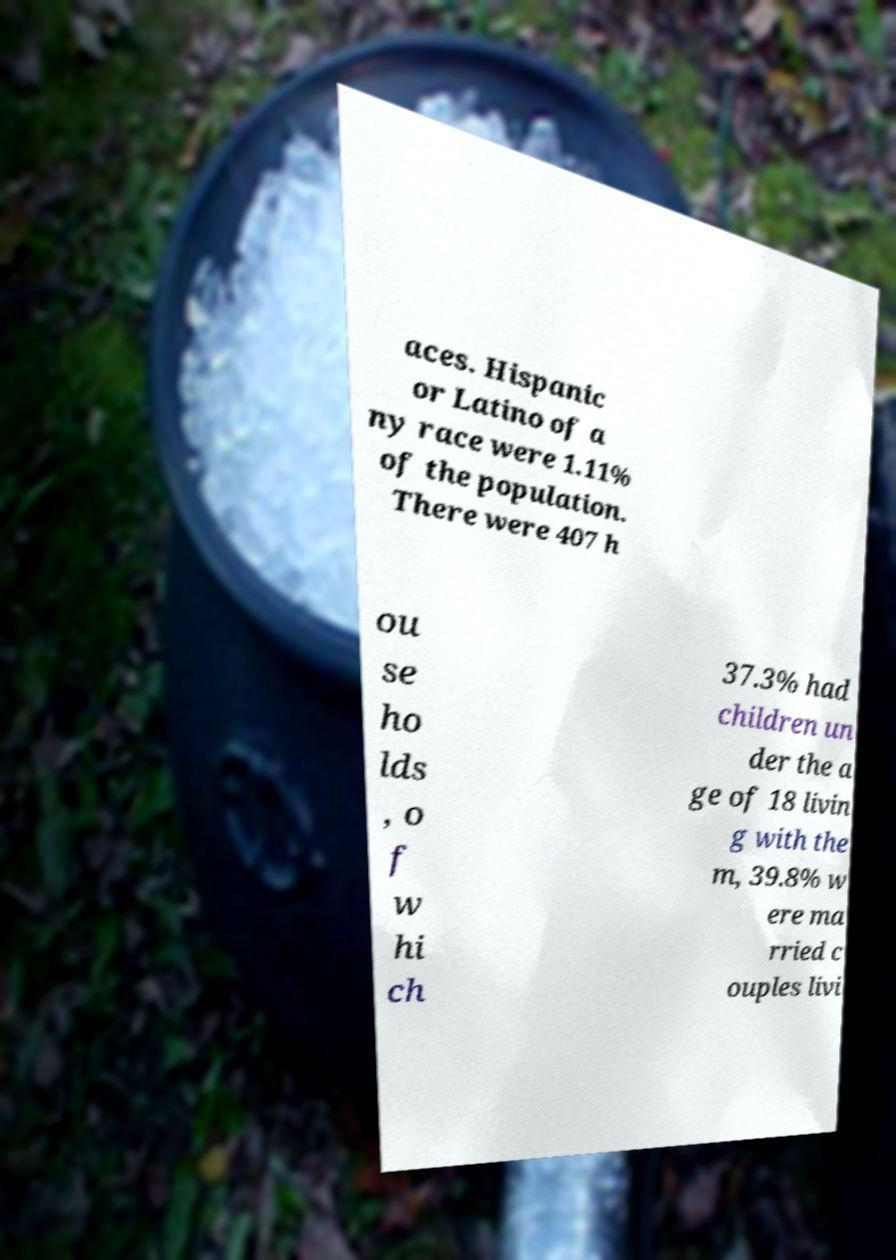I need the written content from this picture converted into text. Can you do that? aces. Hispanic or Latino of a ny race were 1.11% of the population. There were 407 h ou se ho lds , o f w hi ch 37.3% had children un der the a ge of 18 livin g with the m, 39.8% w ere ma rried c ouples livi 